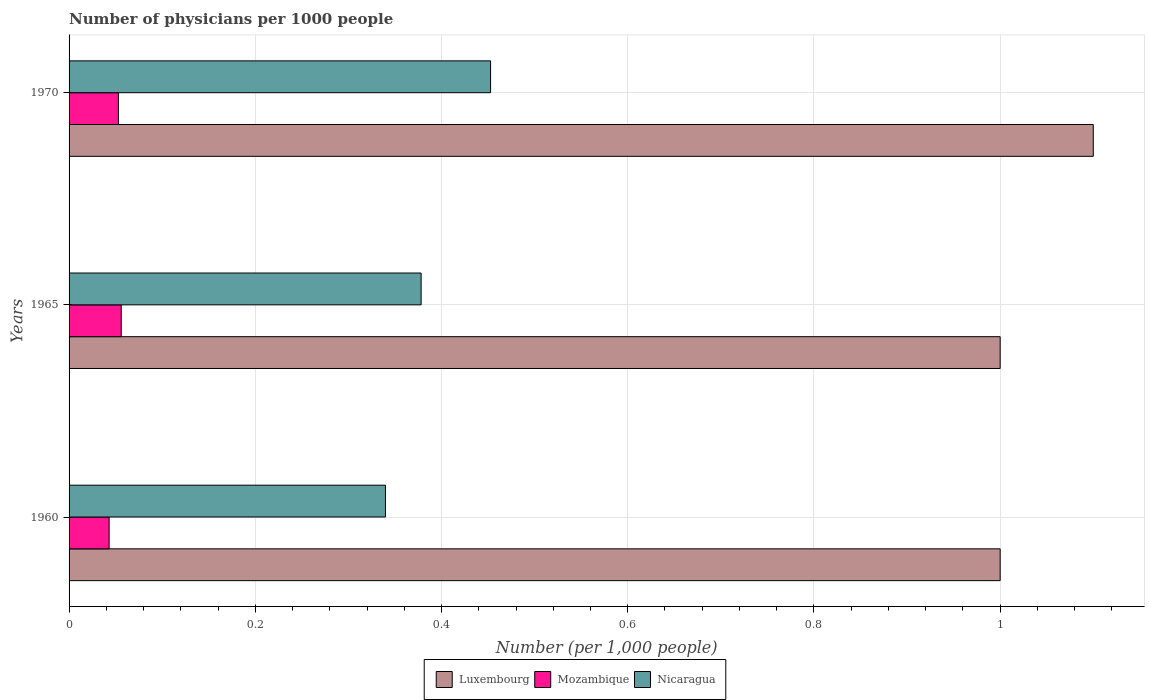Are the number of bars per tick equal to the number of legend labels?
Ensure brevity in your answer.  Yes. How many bars are there on the 2nd tick from the top?
Give a very brief answer. 3. How many bars are there on the 1st tick from the bottom?
Offer a very short reply. 3. What is the label of the 2nd group of bars from the top?
Provide a succinct answer. 1965. What is the number of physicians in Nicaragua in 1970?
Provide a short and direct response. 0.45. Across all years, what is the maximum number of physicians in Mozambique?
Provide a short and direct response. 0.06. Across all years, what is the minimum number of physicians in Nicaragua?
Provide a short and direct response. 0.34. In which year was the number of physicians in Luxembourg maximum?
Give a very brief answer. 1970. In which year was the number of physicians in Luxembourg minimum?
Make the answer very short. 1960. What is the total number of physicians in Mozambique in the graph?
Offer a very short reply. 0.15. What is the difference between the number of physicians in Nicaragua in 1965 and that in 1970?
Offer a very short reply. -0.07. What is the difference between the number of physicians in Luxembourg in 1965 and the number of physicians in Mozambique in 1960?
Your answer should be compact. 0.96. What is the average number of physicians in Nicaragua per year?
Your response must be concise. 0.39. In the year 1965, what is the difference between the number of physicians in Luxembourg and number of physicians in Nicaragua?
Provide a succinct answer. 0.62. What is the ratio of the number of physicians in Mozambique in 1965 to that in 1970?
Offer a very short reply. 1.06. Is the number of physicians in Luxembourg in 1960 less than that in 1965?
Offer a very short reply. No. Is the difference between the number of physicians in Luxembourg in 1960 and 1965 greater than the difference between the number of physicians in Nicaragua in 1960 and 1965?
Your response must be concise. Yes. What is the difference between the highest and the second highest number of physicians in Luxembourg?
Ensure brevity in your answer.  0.1. What is the difference between the highest and the lowest number of physicians in Mozambique?
Your answer should be very brief. 0.01. What does the 1st bar from the top in 1960 represents?
Give a very brief answer. Nicaragua. What does the 3rd bar from the bottom in 1970 represents?
Provide a succinct answer. Nicaragua. How many bars are there?
Offer a terse response. 9. Are all the bars in the graph horizontal?
Keep it short and to the point. Yes. What is the difference between two consecutive major ticks on the X-axis?
Your response must be concise. 0.2. Does the graph contain any zero values?
Give a very brief answer. No. Where does the legend appear in the graph?
Ensure brevity in your answer.  Bottom center. What is the title of the graph?
Offer a very short reply. Number of physicians per 1000 people. What is the label or title of the X-axis?
Provide a short and direct response. Number (per 1,0 people). What is the label or title of the Y-axis?
Ensure brevity in your answer.  Years. What is the Number (per 1,000 people) of Luxembourg in 1960?
Provide a succinct answer. 1. What is the Number (per 1,000 people) in Mozambique in 1960?
Give a very brief answer. 0.04. What is the Number (per 1,000 people) in Nicaragua in 1960?
Make the answer very short. 0.34. What is the Number (per 1,000 people) in Mozambique in 1965?
Keep it short and to the point. 0.06. What is the Number (per 1,000 people) of Nicaragua in 1965?
Provide a short and direct response. 0.38. What is the Number (per 1,000 people) in Luxembourg in 1970?
Offer a terse response. 1.1. What is the Number (per 1,000 people) in Mozambique in 1970?
Ensure brevity in your answer.  0.05. What is the Number (per 1,000 people) in Nicaragua in 1970?
Your answer should be very brief. 0.45. Across all years, what is the maximum Number (per 1,000 people) in Luxembourg?
Provide a short and direct response. 1.1. Across all years, what is the maximum Number (per 1,000 people) of Mozambique?
Provide a succinct answer. 0.06. Across all years, what is the maximum Number (per 1,000 people) of Nicaragua?
Provide a succinct answer. 0.45. Across all years, what is the minimum Number (per 1,000 people) of Mozambique?
Provide a succinct answer. 0.04. Across all years, what is the minimum Number (per 1,000 people) of Nicaragua?
Offer a terse response. 0.34. What is the total Number (per 1,000 people) in Mozambique in the graph?
Your response must be concise. 0.15. What is the total Number (per 1,000 people) of Nicaragua in the graph?
Keep it short and to the point. 1.17. What is the difference between the Number (per 1,000 people) in Mozambique in 1960 and that in 1965?
Offer a very short reply. -0.01. What is the difference between the Number (per 1,000 people) in Nicaragua in 1960 and that in 1965?
Your answer should be compact. -0.04. What is the difference between the Number (per 1,000 people) in Mozambique in 1960 and that in 1970?
Your answer should be very brief. -0.01. What is the difference between the Number (per 1,000 people) of Nicaragua in 1960 and that in 1970?
Make the answer very short. -0.11. What is the difference between the Number (per 1,000 people) in Mozambique in 1965 and that in 1970?
Your answer should be compact. 0. What is the difference between the Number (per 1,000 people) of Nicaragua in 1965 and that in 1970?
Give a very brief answer. -0.07. What is the difference between the Number (per 1,000 people) of Luxembourg in 1960 and the Number (per 1,000 people) of Mozambique in 1965?
Your response must be concise. 0.94. What is the difference between the Number (per 1,000 people) of Luxembourg in 1960 and the Number (per 1,000 people) of Nicaragua in 1965?
Give a very brief answer. 0.62. What is the difference between the Number (per 1,000 people) of Mozambique in 1960 and the Number (per 1,000 people) of Nicaragua in 1965?
Make the answer very short. -0.34. What is the difference between the Number (per 1,000 people) in Luxembourg in 1960 and the Number (per 1,000 people) in Mozambique in 1970?
Offer a very short reply. 0.95. What is the difference between the Number (per 1,000 people) of Luxembourg in 1960 and the Number (per 1,000 people) of Nicaragua in 1970?
Your response must be concise. 0.55. What is the difference between the Number (per 1,000 people) of Mozambique in 1960 and the Number (per 1,000 people) of Nicaragua in 1970?
Your answer should be compact. -0.41. What is the difference between the Number (per 1,000 people) in Luxembourg in 1965 and the Number (per 1,000 people) in Mozambique in 1970?
Keep it short and to the point. 0.95. What is the difference between the Number (per 1,000 people) of Luxembourg in 1965 and the Number (per 1,000 people) of Nicaragua in 1970?
Your answer should be compact. 0.55. What is the difference between the Number (per 1,000 people) in Mozambique in 1965 and the Number (per 1,000 people) in Nicaragua in 1970?
Your answer should be very brief. -0.4. What is the average Number (per 1,000 people) in Mozambique per year?
Offer a terse response. 0.05. What is the average Number (per 1,000 people) in Nicaragua per year?
Provide a succinct answer. 0.39. In the year 1960, what is the difference between the Number (per 1,000 people) in Luxembourg and Number (per 1,000 people) in Mozambique?
Offer a terse response. 0.96. In the year 1960, what is the difference between the Number (per 1,000 people) of Luxembourg and Number (per 1,000 people) of Nicaragua?
Your response must be concise. 0.66. In the year 1960, what is the difference between the Number (per 1,000 people) of Mozambique and Number (per 1,000 people) of Nicaragua?
Provide a short and direct response. -0.3. In the year 1965, what is the difference between the Number (per 1,000 people) in Luxembourg and Number (per 1,000 people) in Mozambique?
Your answer should be compact. 0.94. In the year 1965, what is the difference between the Number (per 1,000 people) in Luxembourg and Number (per 1,000 people) in Nicaragua?
Provide a succinct answer. 0.62. In the year 1965, what is the difference between the Number (per 1,000 people) of Mozambique and Number (per 1,000 people) of Nicaragua?
Ensure brevity in your answer.  -0.32. In the year 1970, what is the difference between the Number (per 1,000 people) in Luxembourg and Number (per 1,000 people) in Mozambique?
Your answer should be very brief. 1.05. In the year 1970, what is the difference between the Number (per 1,000 people) of Luxembourg and Number (per 1,000 people) of Nicaragua?
Give a very brief answer. 0.65. In the year 1970, what is the difference between the Number (per 1,000 people) in Mozambique and Number (per 1,000 people) in Nicaragua?
Keep it short and to the point. -0.4. What is the ratio of the Number (per 1,000 people) in Luxembourg in 1960 to that in 1965?
Provide a short and direct response. 1. What is the ratio of the Number (per 1,000 people) in Mozambique in 1960 to that in 1965?
Give a very brief answer. 0.77. What is the ratio of the Number (per 1,000 people) of Nicaragua in 1960 to that in 1965?
Make the answer very short. 0.9. What is the ratio of the Number (per 1,000 people) in Luxembourg in 1960 to that in 1970?
Provide a short and direct response. 0.91. What is the ratio of the Number (per 1,000 people) in Mozambique in 1960 to that in 1970?
Your answer should be very brief. 0.81. What is the ratio of the Number (per 1,000 people) in Nicaragua in 1960 to that in 1970?
Offer a very short reply. 0.75. What is the ratio of the Number (per 1,000 people) of Mozambique in 1965 to that in 1970?
Offer a very short reply. 1.06. What is the ratio of the Number (per 1,000 people) in Nicaragua in 1965 to that in 1970?
Your answer should be compact. 0.84. What is the difference between the highest and the second highest Number (per 1,000 people) in Mozambique?
Offer a terse response. 0. What is the difference between the highest and the second highest Number (per 1,000 people) in Nicaragua?
Keep it short and to the point. 0.07. What is the difference between the highest and the lowest Number (per 1,000 people) in Luxembourg?
Provide a succinct answer. 0.1. What is the difference between the highest and the lowest Number (per 1,000 people) of Mozambique?
Offer a very short reply. 0.01. What is the difference between the highest and the lowest Number (per 1,000 people) of Nicaragua?
Make the answer very short. 0.11. 